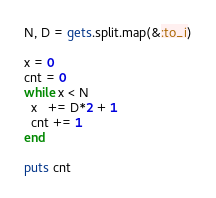Convert code to text. <code><loc_0><loc_0><loc_500><loc_500><_Ruby_>N, D = gets.split.map(&:to_i)

x = 0
cnt = 0
while x < N
  x   += D*2 + 1
  cnt += 1
end

puts cnt</code> 